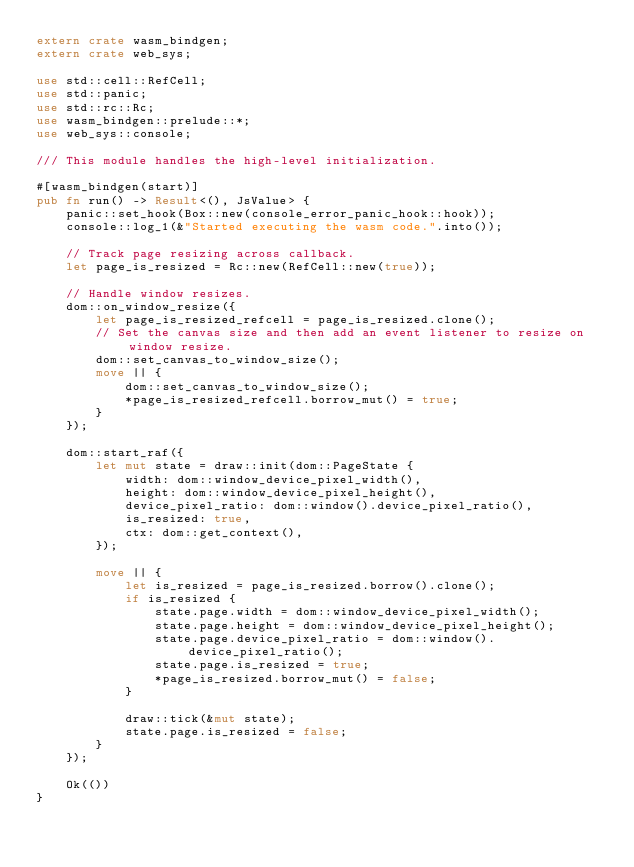<code> <loc_0><loc_0><loc_500><loc_500><_Rust_>extern crate wasm_bindgen;
extern crate web_sys;

use std::cell::RefCell;
use std::panic;
use std::rc::Rc;
use wasm_bindgen::prelude::*;
use web_sys::console;

/// This module handles the high-level initialization.

#[wasm_bindgen(start)]
pub fn run() -> Result<(), JsValue> {
    panic::set_hook(Box::new(console_error_panic_hook::hook));
    console::log_1(&"Started executing the wasm code.".into());

    // Track page resizing across callback.
    let page_is_resized = Rc::new(RefCell::new(true));

    // Handle window resizes.
    dom::on_window_resize({
        let page_is_resized_refcell = page_is_resized.clone();
        // Set the canvas size and then add an event listener to resize on window resize.
        dom::set_canvas_to_window_size();
        move || {
            dom::set_canvas_to_window_size();
            *page_is_resized_refcell.borrow_mut() = true;
        }
    });

    dom::start_raf({
        let mut state = draw::init(dom::PageState {
            width: dom::window_device_pixel_width(),
            height: dom::window_device_pixel_height(),
            device_pixel_ratio: dom::window().device_pixel_ratio(),
            is_resized: true,
            ctx: dom::get_context(),
        });

        move || {
            let is_resized = page_is_resized.borrow().clone();
            if is_resized {
                state.page.width = dom::window_device_pixel_width();
                state.page.height = dom::window_device_pixel_height();
                state.page.device_pixel_ratio = dom::window().device_pixel_ratio();
                state.page.is_resized = true;
                *page_is_resized.borrow_mut() = false;
            }

            draw::tick(&mut state);
            state.page.is_resized = false;
        }
    });

    Ok(())
}
</code> 